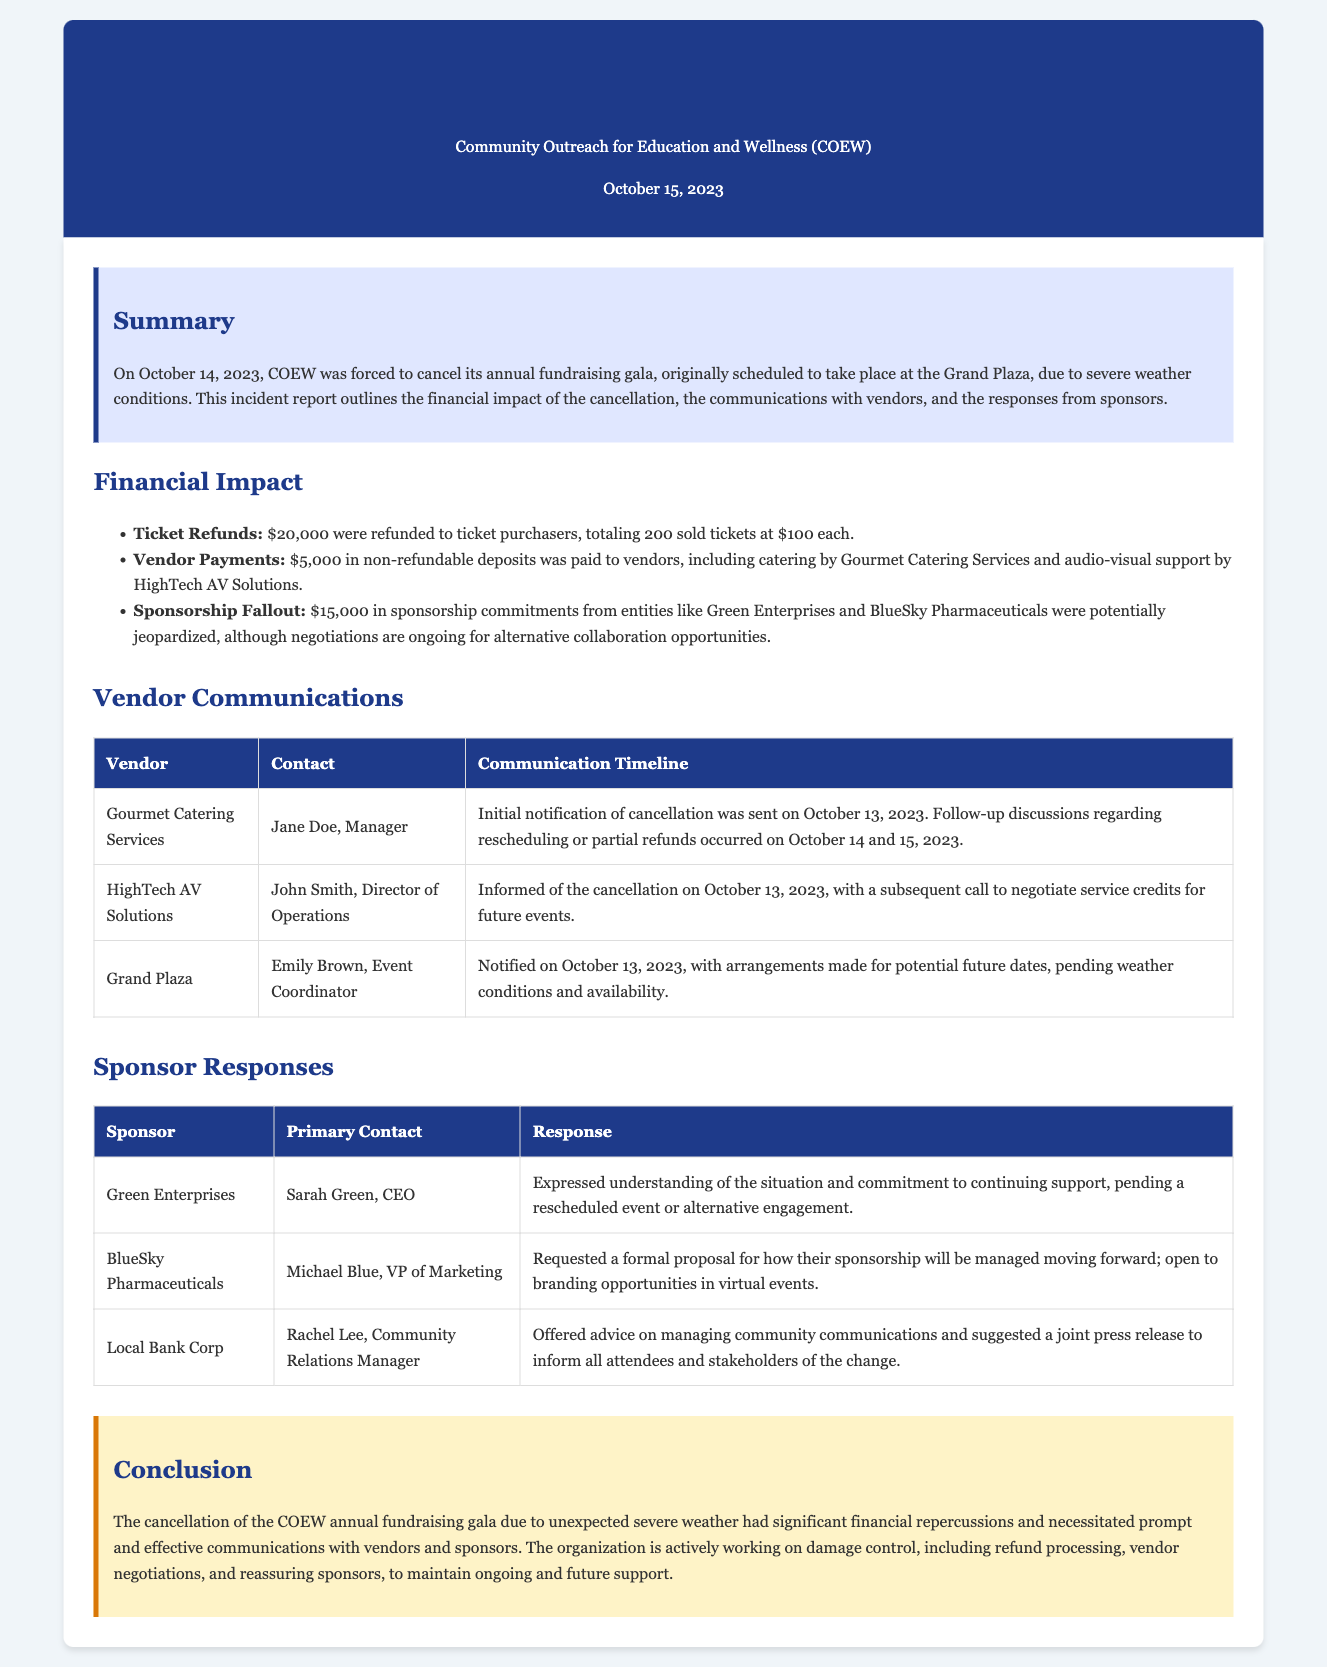What date was the event scheduled? The event was originally scheduled for October 14, 2023, as noted in the incident report summary.
Answer: October 14, 2023 What was the total amount refunded for tickets? The document specifies that $20,000 was refunded to ticket purchasers for a total of 200 sold tickets.
Answer: $20,000 Who is the contact person for Gourmet Catering Services? The incident report lists Jane Doe as the Manager of Gourmet Catering Services, indicating her as the contact for vendor communications.
Answer: Jane Doe What was the non-refundable deposit paid to vendors? The financial impact section indicates that $5,000 in non-refundable deposits was paid to vendors.
Answer: $5,000 How much sponsorship commitment was jeopardized? The report outlines that $15,000 in sponsorship commitments were potentially jeopardized due to the cancellation.
Answer: $15,000 What advice did Local Bank Corp offer? Local Bank Corp suggested managing community communications and proposed a joint press release to inform attendees.
Answer: Joint press release What was the response of Green Enterprises? The report states that Green Enterprises expressed understanding of the situation and commitment to continue support.
Answer: Understanding and commitment When was the initial notification of cancellation sent to vendors? The document notes that the initial notifications were sent on October 13, 2023, to the vendors regarding the event cancellation.
Answer: October 13, 2023 What is the title of this document? The header of the document clearly states that this is an incident report regarding a major event cancellation.
Answer: Incident Report: Major Event Cancellation 